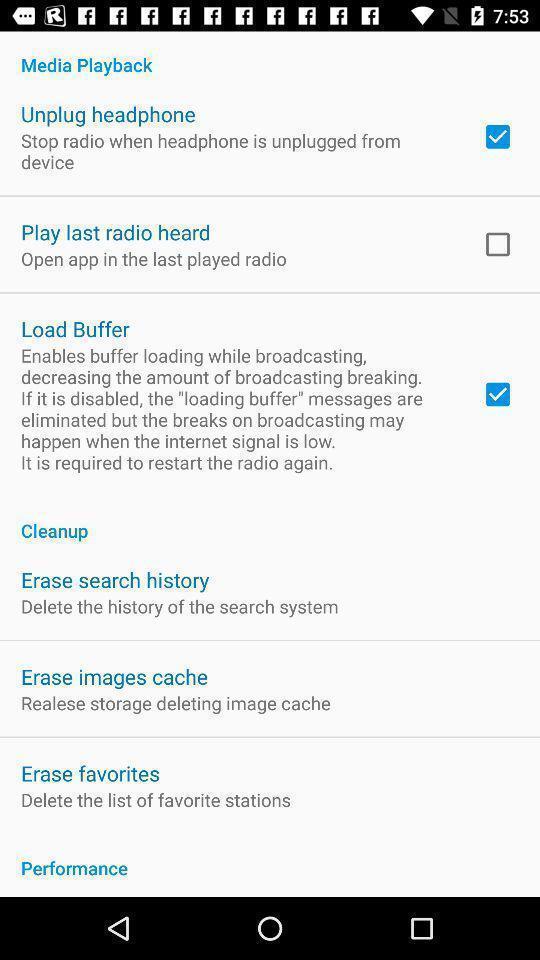Provide a description of this screenshot. Screen displaying list of various settings. 